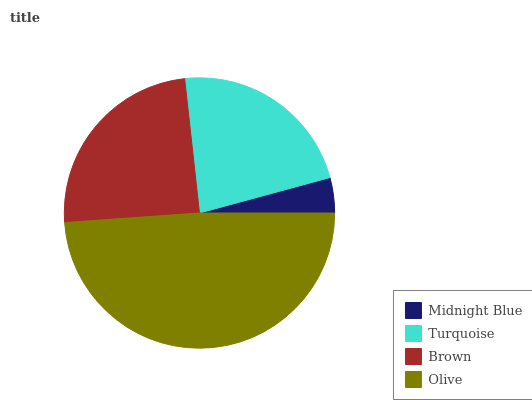Is Midnight Blue the minimum?
Answer yes or no. Yes. Is Olive the maximum?
Answer yes or no. Yes. Is Turquoise the minimum?
Answer yes or no. No. Is Turquoise the maximum?
Answer yes or no. No. Is Turquoise greater than Midnight Blue?
Answer yes or no. Yes. Is Midnight Blue less than Turquoise?
Answer yes or no. Yes. Is Midnight Blue greater than Turquoise?
Answer yes or no. No. Is Turquoise less than Midnight Blue?
Answer yes or no. No. Is Brown the high median?
Answer yes or no. Yes. Is Turquoise the low median?
Answer yes or no. Yes. Is Midnight Blue the high median?
Answer yes or no. No. Is Midnight Blue the low median?
Answer yes or no. No. 